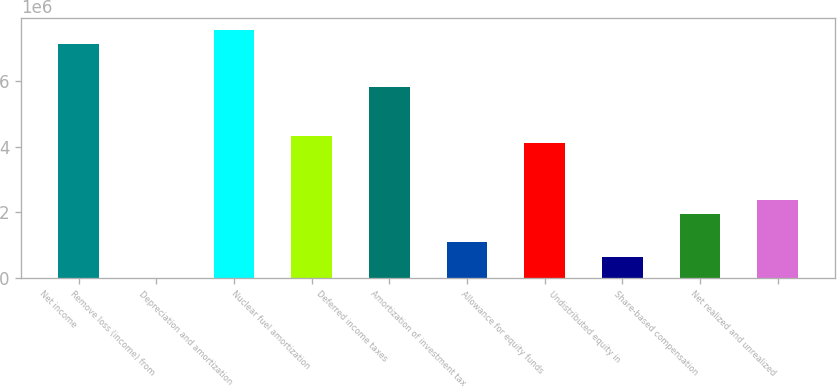Convert chart to OTSL. <chart><loc_0><loc_0><loc_500><loc_500><bar_chart><fcel>Net income<fcel>Remove loss (income) from<fcel>Depreciation and amortization<fcel>Nuclear fuel amortization<fcel>Deferred income taxes<fcel>Amortization of investment tax<fcel>Allowance for equity funds<fcel>Undistributed equity in<fcel>Share-based compensation<fcel>Net realized and unrealized<nl><fcel>7.11546e+06<fcel>166<fcel>7.54669e+06<fcel>4.31247e+06<fcel>5.82177e+06<fcel>1.07824e+06<fcel>4.09685e+06<fcel>647011<fcel>1.9407e+06<fcel>2.37193e+06<nl></chart> 